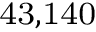Convert formula to latex. <formula><loc_0><loc_0><loc_500><loc_500>^ { 4 } 3 , 1 4 0</formula> 